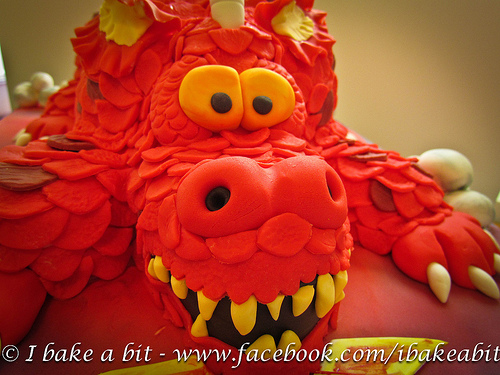<image>
Can you confirm if the toothpick is to the left of the bottle? No. The toothpick is not to the left of the bottle. From this viewpoint, they have a different horizontal relationship. Is there a tooth in front of the nostril? No. The tooth is not in front of the nostril. The spatial positioning shows a different relationship between these objects. Where is the teeth in relation to the pop? Is it in front of the pop? No. The teeth is not in front of the pop. The spatial positioning shows a different relationship between these objects. 